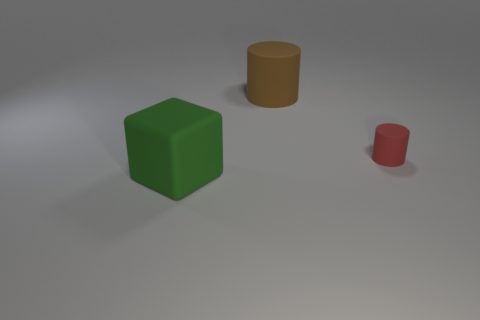Thinking in terms of physics, how do the shadows inform us about the light source? The shadows in the image are cast on the ground to the right of each object, suggesting that the light source originates from the top left side of the visual field. This provides a clue about the positioning and intensity of the light, giving depth to the scene and adding dimension to the objects. 